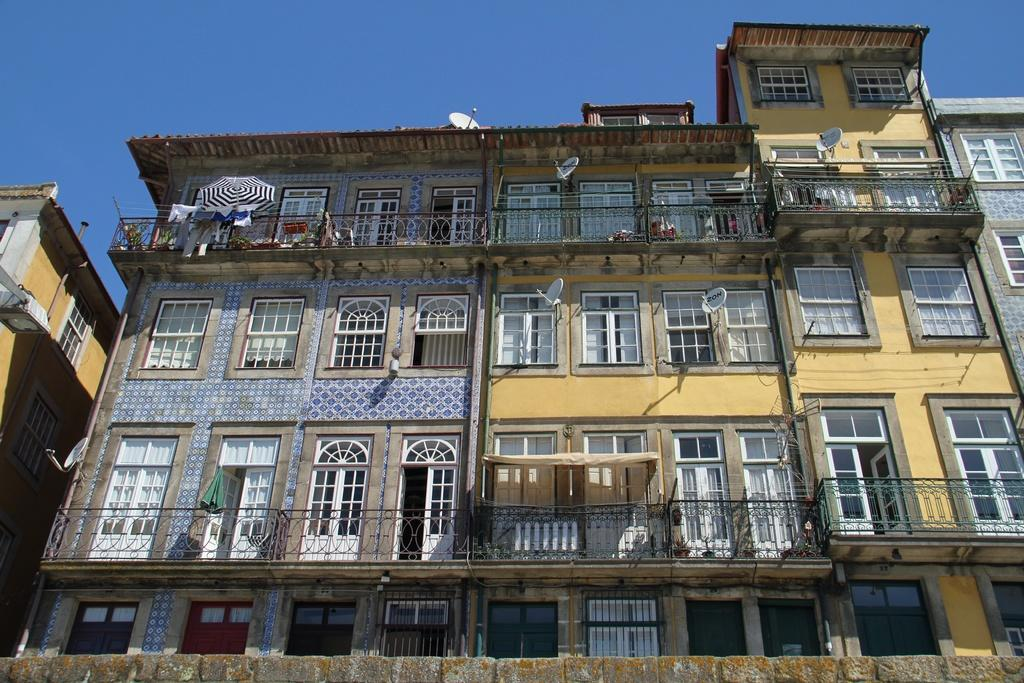What is the main subject of the image? The main subject of the image is a building. Can you describe the building in the image? The building is in the center of the image and has many windows. What type of celery is being used as a support beam in the building? There is no celery present in the image, and therefore it cannot be used as a support beam in the building. 